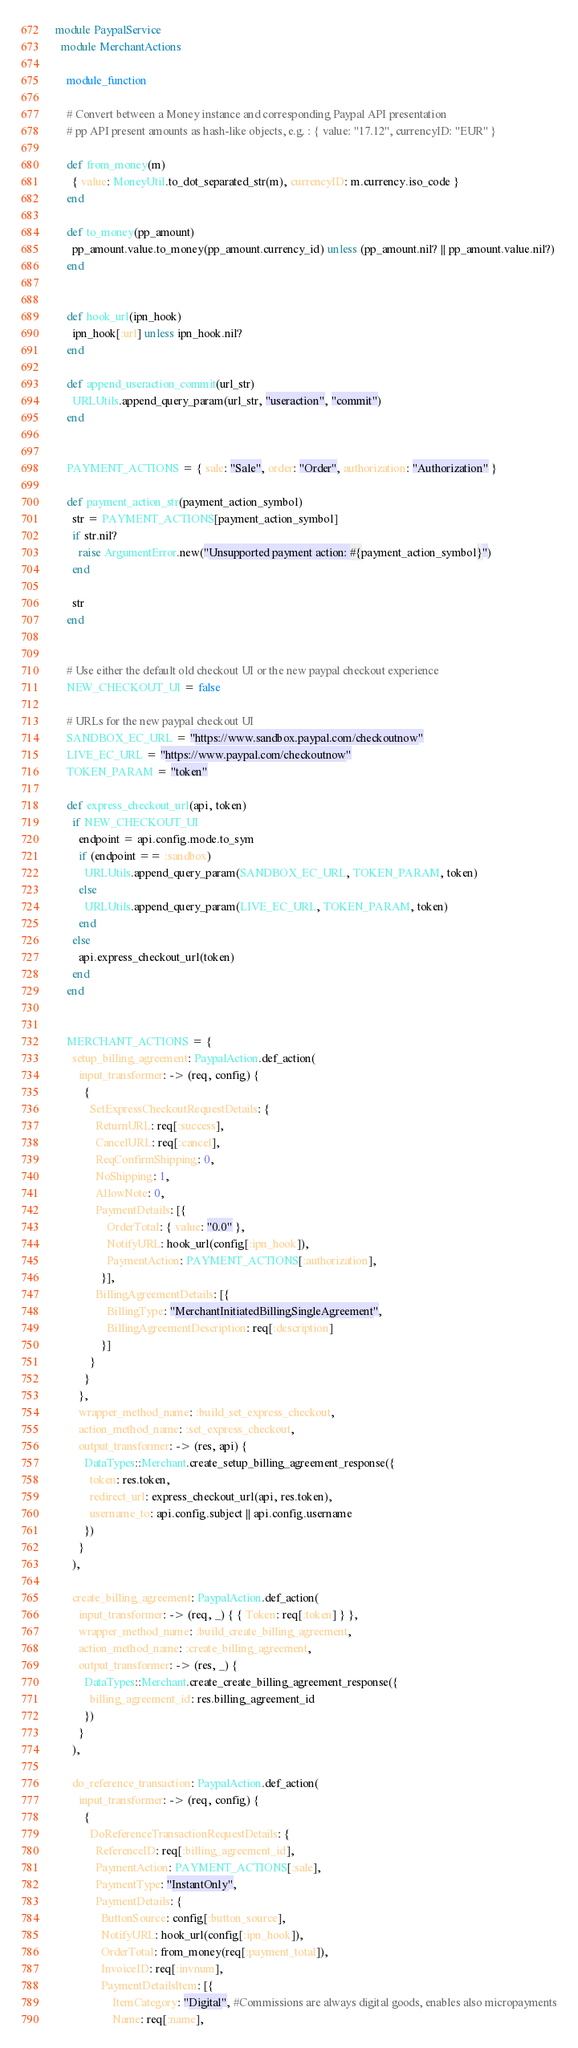<code> <loc_0><loc_0><loc_500><loc_500><_Ruby_>module PaypalService
  module MerchantActions

    module_function

    # Convert between a Money instance and corresponding Paypal API presentation
    # pp API present amounts as hash-like objects, e.g. : { value: "17.12", currencyID: "EUR" }

    def from_money(m)
      { value: MoneyUtil.to_dot_separated_str(m), currencyID: m.currency.iso_code }
    end

    def to_money(pp_amount)
      pp_amount.value.to_money(pp_amount.currency_id) unless (pp_amount.nil? || pp_amount.value.nil?)
    end


    def hook_url(ipn_hook)
      ipn_hook[:url] unless ipn_hook.nil?
    end

    def append_useraction_commit(url_str)
      URLUtils.append_query_param(url_str, "useraction", "commit")
    end


    PAYMENT_ACTIONS = { sale: "Sale", order: "Order", authorization: "Authorization" }

    def payment_action_str(payment_action_symbol)
      str = PAYMENT_ACTIONS[payment_action_symbol]
      if str.nil?
        raise ArgumentError.new("Unsupported payment action: #{payment_action_symbol}")
      end

      str
    end


    # Use either the default old checkout UI or the new paypal checkout experience
    NEW_CHECKOUT_UI = false

    # URLs for the new paypal checkout UI
    SANDBOX_EC_URL = "https://www.sandbox.paypal.com/checkoutnow"
    LIVE_EC_URL = "https://www.paypal.com/checkoutnow"
    TOKEN_PARAM = "token"

    def express_checkout_url(api, token)
      if NEW_CHECKOUT_UI
        endpoint = api.config.mode.to_sym
        if (endpoint == :sandbox)
          URLUtils.append_query_param(SANDBOX_EC_URL, TOKEN_PARAM, token)
        else
          URLUtils.append_query_param(LIVE_EC_URL, TOKEN_PARAM, token)
        end
      else
        api.express_checkout_url(token)
      end
    end


    MERCHANT_ACTIONS = {
      setup_billing_agreement: PaypalAction.def_action(
        input_transformer: -> (req, config) {
          {
            SetExpressCheckoutRequestDetails: {
              ReturnURL: req[:success],
              CancelURL: req[:cancel],
              ReqConfirmShipping: 0,
              NoShipping: 1,
              AllowNote: 0,
              PaymentDetails: [{
                  OrderTotal: { value: "0.0" },
                  NotifyURL: hook_url(config[:ipn_hook]),
                  PaymentAction: PAYMENT_ACTIONS[:authorization],
                }],
              BillingAgreementDetails: [{
                  BillingType: "MerchantInitiatedBillingSingleAgreement",
                  BillingAgreementDescription: req[:description]
                }]
            }
          }
        },
        wrapper_method_name: :build_set_express_checkout,
        action_method_name: :set_express_checkout,
        output_transformer: -> (res, api) {
          DataTypes::Merchant.create_setup_billing_agreement_response({
            token: res.token,
            redirect_url: express_checkout_url(api, res.token),
            username_to: api.config.subject || api.config.username
          })
        }
      ),

      create_billing_agreement: PaypalAction.def_action(
        input_transformer: -> (req, _) { { Token: req[:token] } },
        wrapper_method_name: :build_create_billing_agreement,
        action_method_name: :create_billing_agreement,
        output_transformer: -> (res, _) {
          DataTypes::Merchant.create_create_billing_agreement_response({
            billing_agreement_id: res.billing_agreement_id
          })
        }
      ),

      do_reference_transaction: PaypalAction.def_action(
        input_transformer: -> (req, config) {
          {
            DoReferenceTransactionRequestDetails: {
              ReferenceID: req[:billing_agreement_id],
              PaymentAction: PAYMENT_ACTIONS[:sale],
              PaymentType: "InstantOnly",
              PaymentDetails: {
                ButtonSource: config[:button_source],
                NotifyURL: hook_url(config[:ipn_hook]),
                OrderTotal: from_money(req[:payment_total]),
                InvoiceID: req[:invnum],
                PaymentDetailsItem: [{
                    ItemCategory: "Digital", #Commissions are always digital goods, enables also micropayments
                    Name: req[:name],</code> 